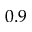Convert formula to latex. <formula><loc_0><loc_0><loc_500><loc_500>0 . 9</formula> 